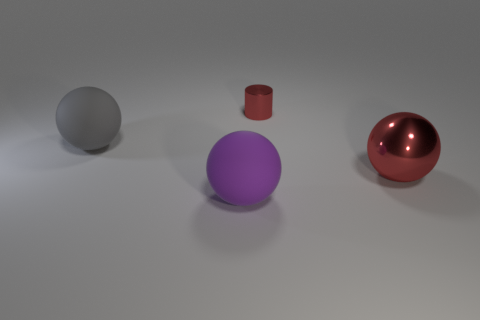Suppose this is a scene from a story. Can you describe what might be happening or what the story is about? In the context of a story, this scene could represent a moment of quiet reflection in a character's life. The stark setting and placement of the objects might symbolize the choices or paths available to the protagonist, with the cylinder acting as a pivotal point or barrier between the mundane grey sphere and the enticing red sphere, which could symbolize temptation or passion. 